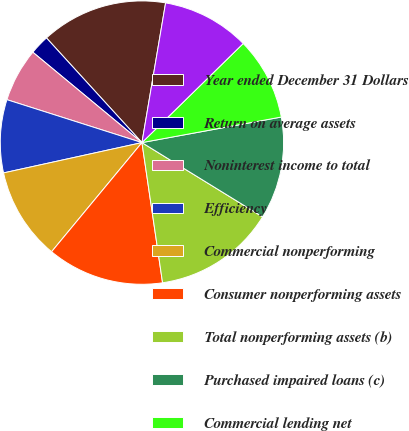Convert chart to OTSL. <chart><loc_0><loc_0><loc_500><loc_500><pie_chart><fcel>Year ended December 31 Dollars<fcel>Return on average assets<fcel>Noninterest income to total<fcel>Efficiency<fcel>Commercial nonperforming<fcel>Consumer nonperforming assets<fcel>Total nonperforming assets (b)<fcel>Purchased impaired loans (c)<fcel>Commercial lending net<fcel>Credit card lending net<nl><fcel>14.44%<fcel>2.22%<fcel>6.11%<fcel>8.33%<fcel>10.56%<fcel>13.33%<fcel>13.89%<fcel>11.67%<fcel>9.44%<fcel>10.0%<nl></chart> 